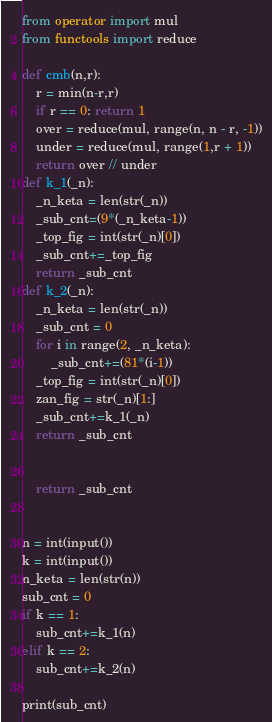Convert code to text. <code><loc_0><loc_0><loc_500><loc_500><_Python_>from operator import mul
from functools import reduce

def cmb(n,r):
    r = min(n-r,r)
    if r == 0: return 1
    over = reduce(mul, range(n, n - r, -1))
    under = reduce(mul, range(1,r + 1))
    return over // under
def k_1(_n):
    _n_keta = len(str(_n))
    _sub_cnt=(9*(_n_keta-1))
    _top_fig = int(str(_n)[0])
    _sub_cnt+=_top_fig
    return _sub_cnt
def k_2(_n):
    _n_keta = len(str(_n))
    _sub_cnt = 0
    for i in range(2, _n_keta):
        _sub_cnt+=(81*(i-1))
    _top_fig = int(str(_n)[0])
    zan_fig = str(_n)[1:]
    _sub_cnt+=k_1(_n)
    return _sub_cnt


    return _sub_cnt


n = int(input())
k = int(input())
n_keta = len(str(n))
sub_cnt = 0
if k == 1:
    sub_cnt+=k_1(n)
elif k == 2:
    sub_cnt+=k_2(n)

print(sub_cnt)
</code> 